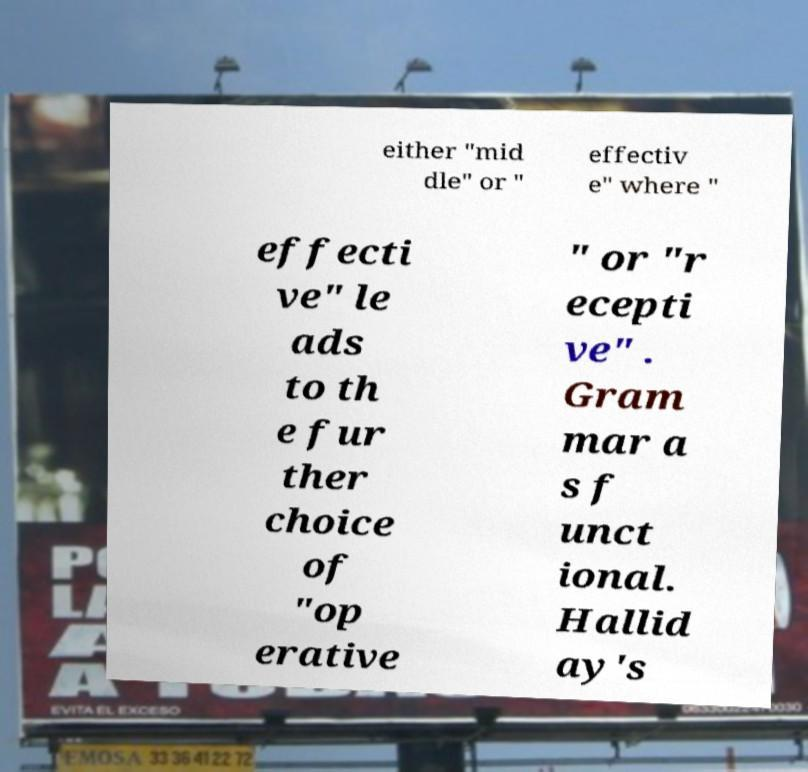Could you assist in decoding the text presented in this image and type it out clearly? either "mid dle" or " effectiv e" where " effecti ve" le ads to th e fur ther choice of "op erative " or "r ecepti ve" . Gram mar a s f unct ional. Hallid ay's 